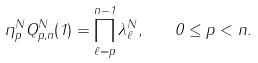Convert formula to latex. <formula><loc_0><loc_0><loc_500><loc_500>\eta _ { p } ^ { N } Q _ { p , n } ^ { N } ( 1 ) = \prod _ { \ell = p } ^ { n - 1 } \lambda _ { \ell } ^ { N } , \quad 0 \leq p < n .</formula> 